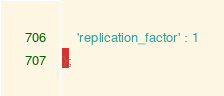Convert code to text. <code><loc_0><loc_0><loc_500><loc_500><_SQL_>	'replication_factor' : 1
};

</code> 